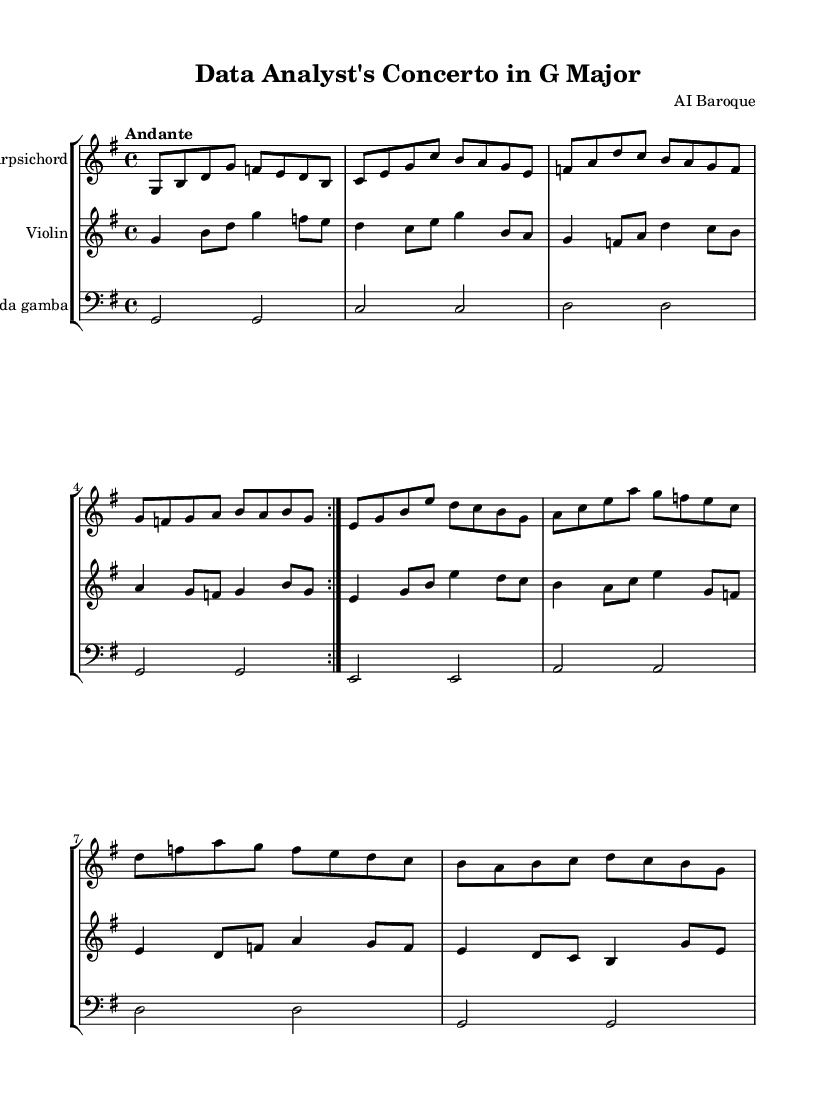What is the key signature of this music? The key signature is G major, which has one sharp (F#). It can be identified in the beginning of the sheet music, just after the clef symbol.
Answer: G major What is the time signature of this piece? The time signature indicated in the sheet music is 4/4, which means there are four beats in each measure and the quarter note receives one beat. This can be observed at the beginning of the score, next to the key signature.
Answer: 4/4 What is the tempo marking for this concerto? The tempo marking is Andante, which typically indicates a moderate walking pace. This is stated at the start of the music just above the clef and time signature.
Answer: Andante How many measures are in the harpsichord part? The harpsichord part contains eight measures, as indicated by counting the groupings of notes separated by bar lines throughout the section.
Answer: Eight What instruments are featured in this chamber music? The featured instruments are the Harpsichord, Violin, and Viola da gamba. This information is presented at the beginning of each staff, where each instrument is labeled.
Answer: Harpsichord, Violin, Viola da gamba Which section consists of repeated material? The section with repeated material is the harpsichord part, specifically the first four measures, which are marked with a repeat sign. This indicates that those measures should be played again.
Answer: Harpsichord part What style of music does this piece represent? This piece represents Baroque music, characterized by a focus on ornamentation, contrast, and expressive melodies. The musical structure and instrumentation reflect the typical characteristics of the Baroque period.
Answer: Baroque 